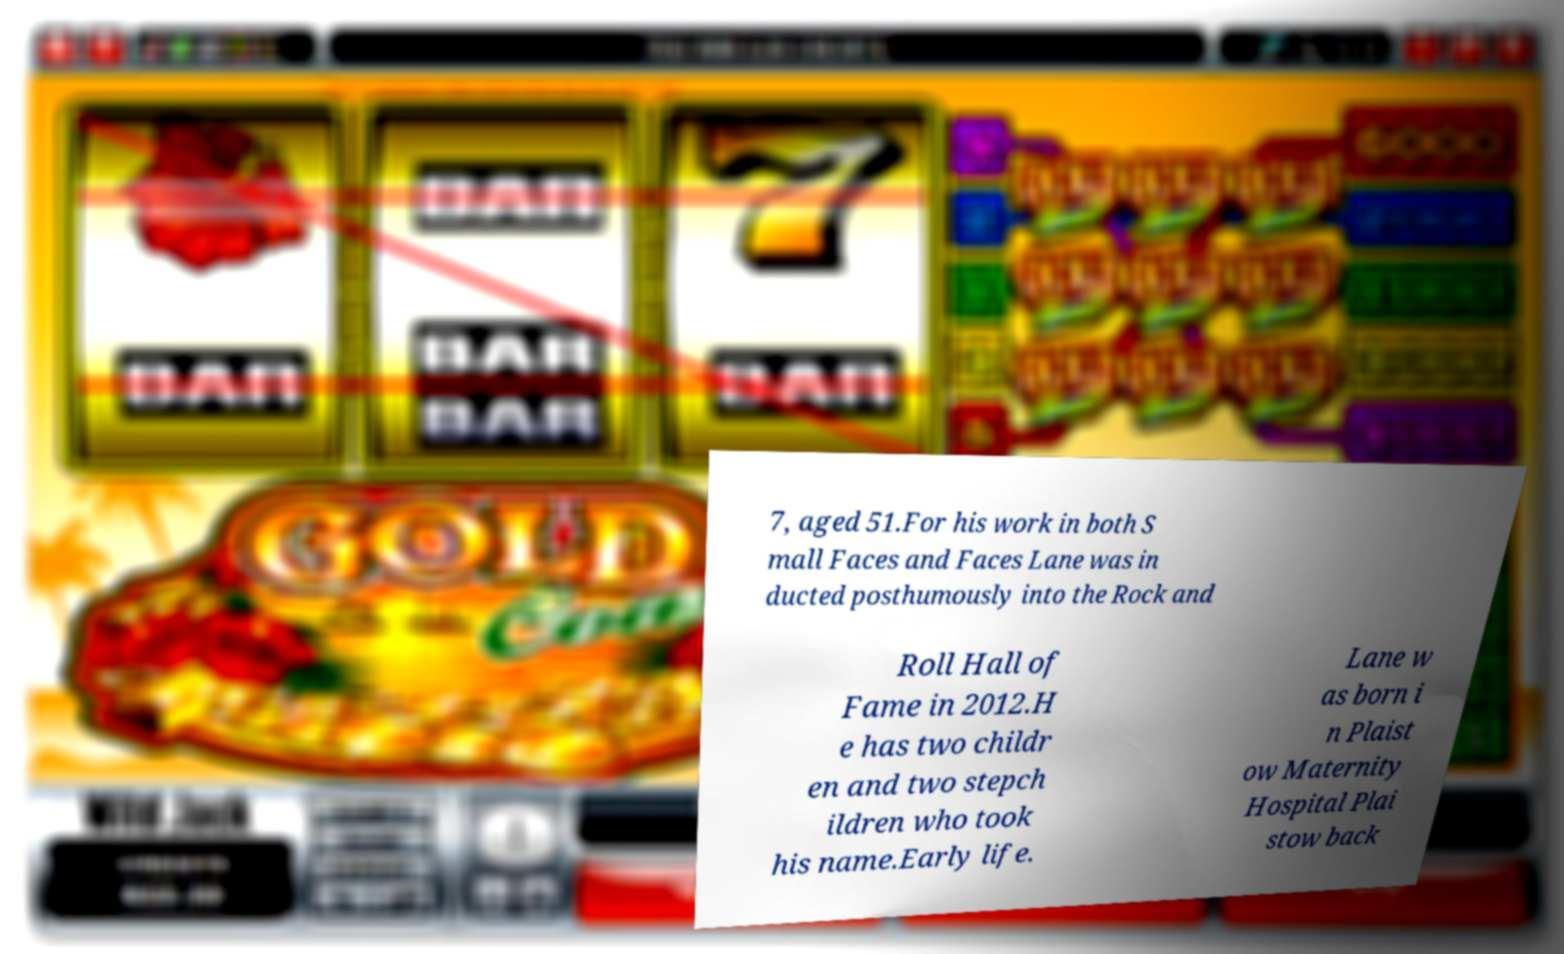I need the written content from this picture converted into text. Can you do that? 7, aged 51.For his work in both S mall Faces and Faces Lane was in ducted posthumously into the Rock and Roll Hall of Fame in 2012.H e has two childr en and two stepch ildren who took his name.Early life. Lane w as born i n Plaist ow Maternity Hospital Plai stow back 